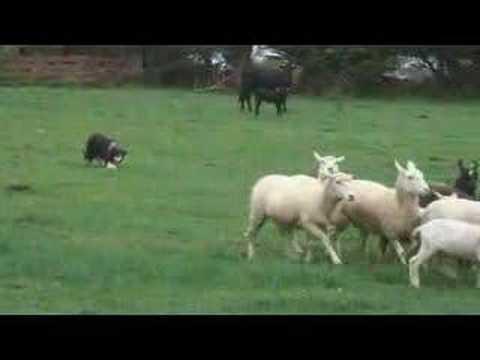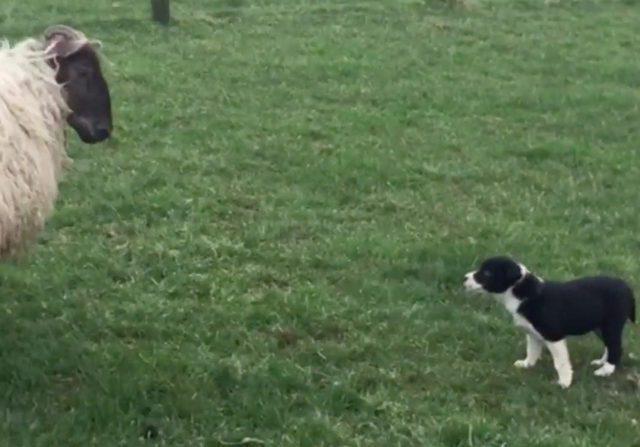The first image is the image on the left, the second image is the image on the right. Considering the images on both sides, is "The right image contains exactly three sheep." valid? Answer yes or no. No. The first image is the image on the left, the second image is the image on the right. Evaluate the accuracy of this statement regarding the images: "There are less than three animals in one of the images.". Is it true? Answer yes or no. Yes. 